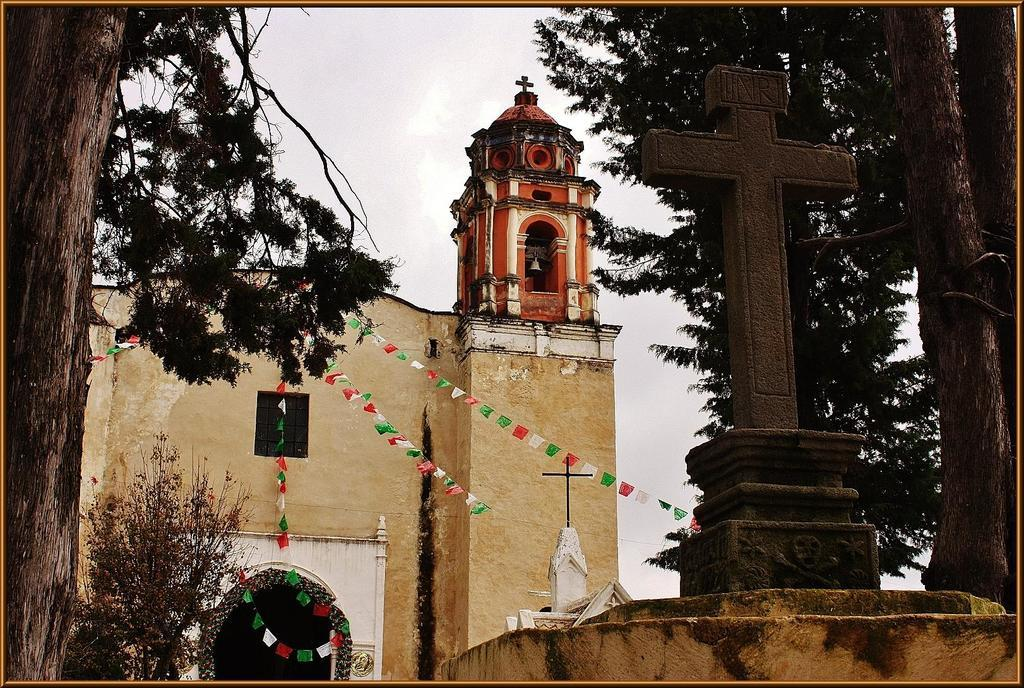What religious symbol can be seen in the image? There is a holy cross symbol in the image. What type of structure is visible in the image? There is a building with a window in the image. What is hanging in the image? A bell is hanging in the image. What architectural feature is present in the image? There is an arch in the image. What type of vegetation is present in the image? Trees with branches and leaves are present in the image. What type of flesh can be seen on the trees in the image? There is no flesh present on the trees in the image; they are covered with branches and leaves. 